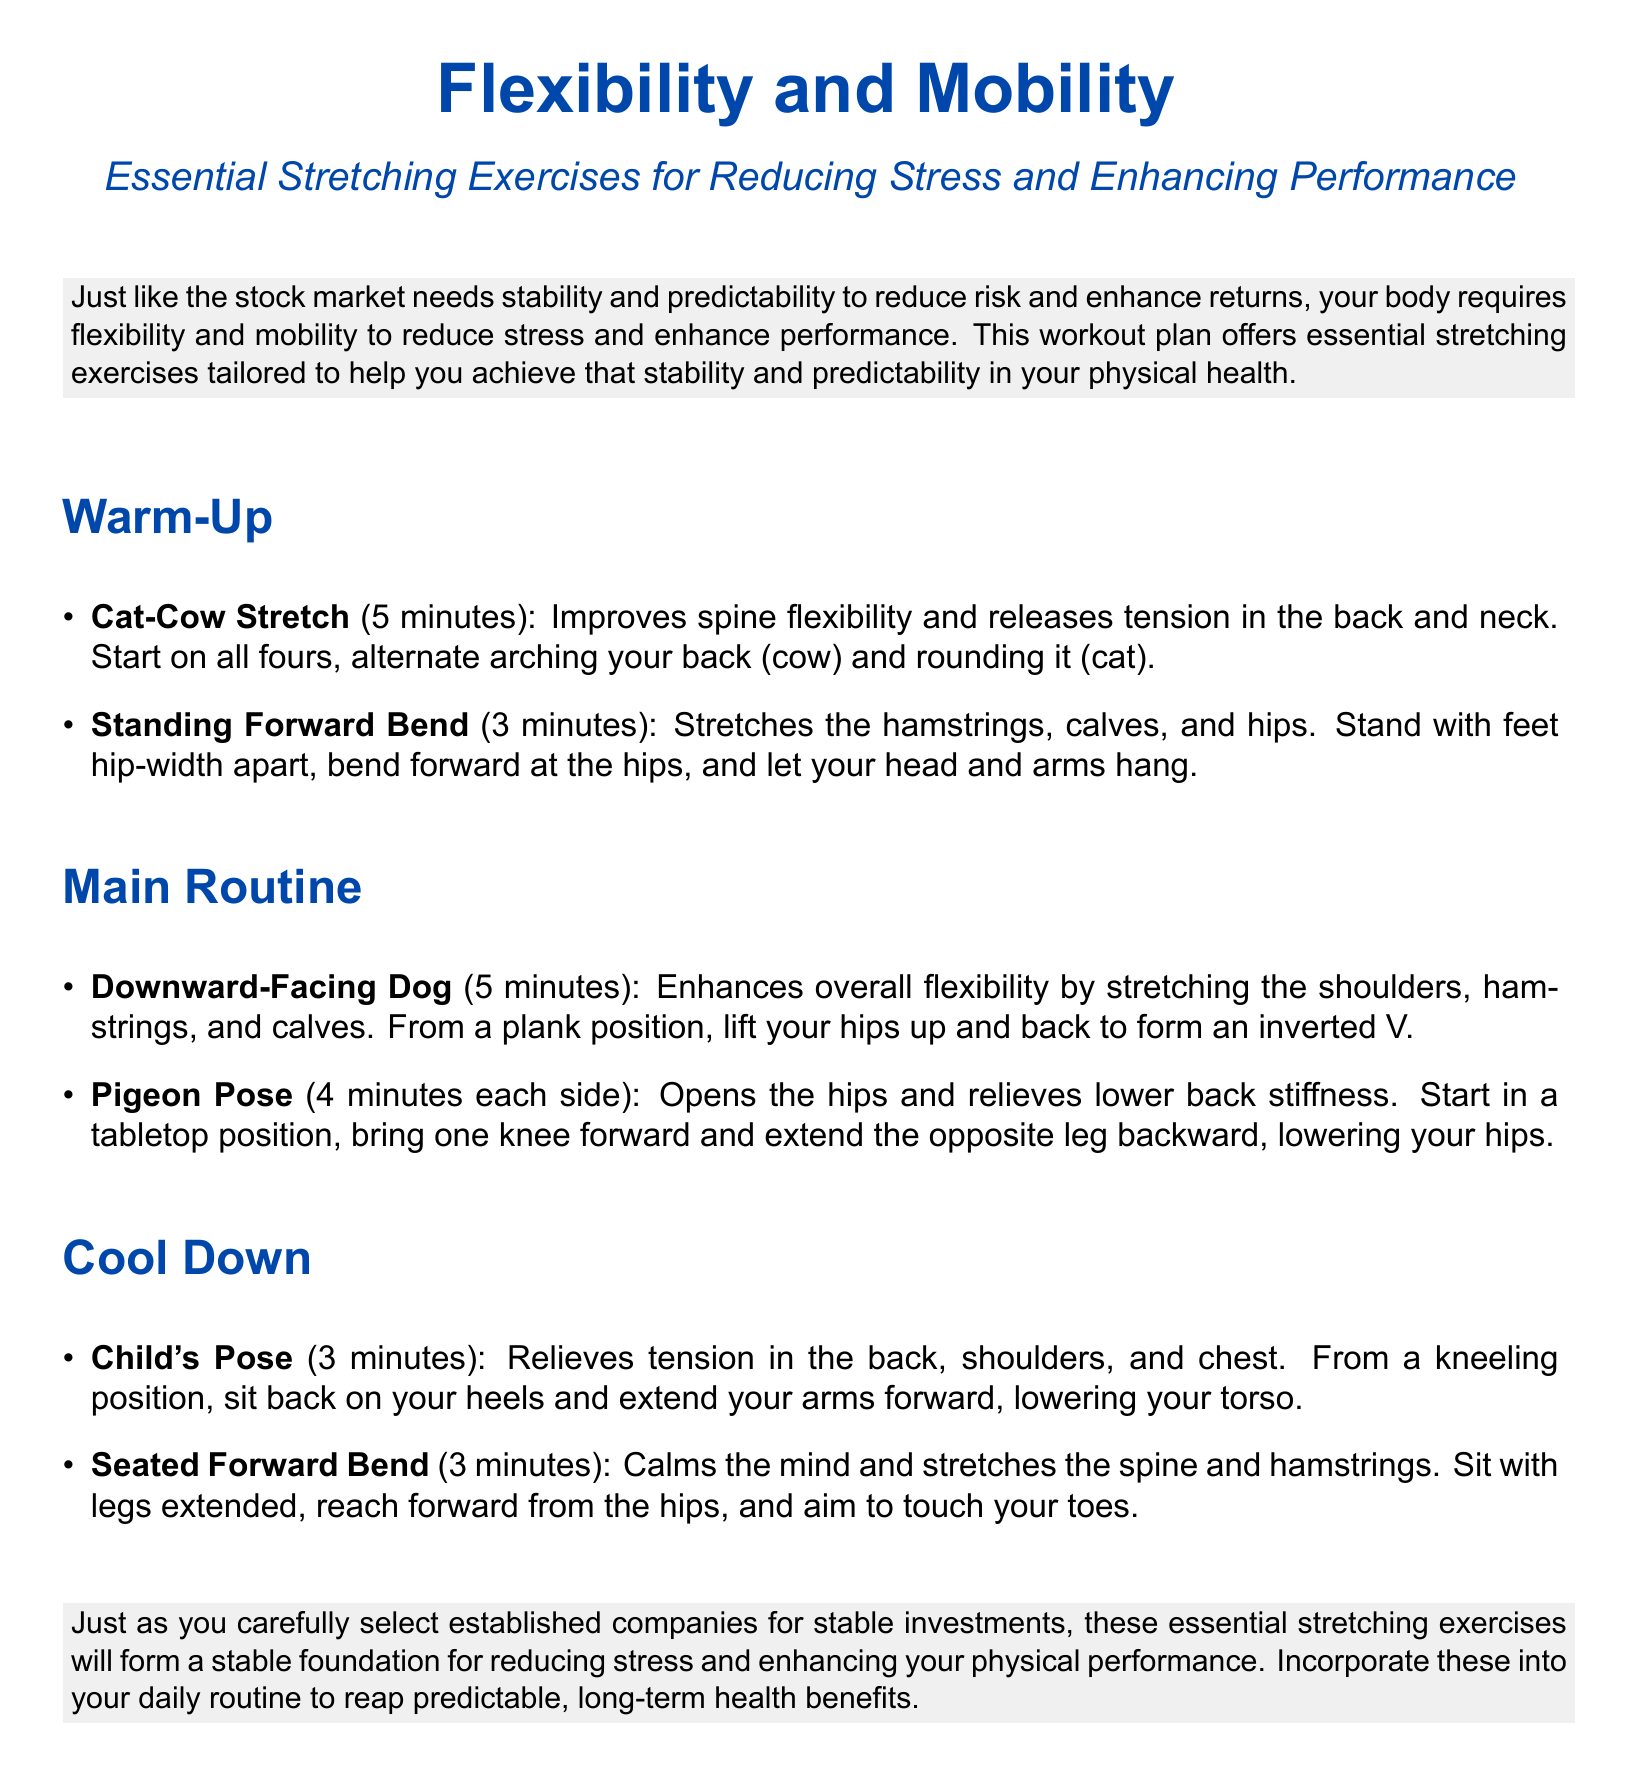what is the first exercise in the warm-up section? The first exercise listed in the warm-up section is the Cat-Cow Stretch.
Answer: Cat-Cow Stretch how long should you hold the Pigeon Pose on each side? The document states that you should hold the Pigeon Pose for 4 minutes on each side.
Answer: 4 minutes what type of document is this? The content is structured as a workout plan focusing on flexibility and mobility.
Answer: workout plan what is the duration of the Standing Forward Bend exercise? The Standing Forward Bend exercise is specified to last for 3 minutes.
Answer: 3 minutes what is emphasized in the introductory paragraph? The introductory paragraph highlights the importance of flexibility and mobility for reducing stress and enhancing performance.
Answer: flexibility and mobility which pose helps relieve tension in the back and shoulders? The Child's Pose is noted for relieving tension in the back, shoulders, and chest.
Answer: Child's Pose what is the goal of this workout plan? The workout plan aims to reduce stress and enhance physical performance through stretching exercises.
Answer: reduce stress and enhance performance how many minutes should be spent on the Downward-Facing Dog? The Downward-Facing Dog exercise should take 5 minutes according to the plan.
Answer: 5 minutes which exercise is intended to calm the mind? The Seated Forward Bend is intended to calm the mind as per the document.
Answer: Seated Forward Bend 